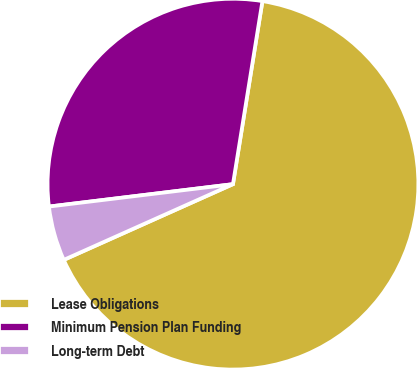Convert chart to OTSL. <chart><loc_0><loc_0><loc_500><loc_500><pie_chart><fcel>Lease Obligations<fcel>Minimum Pension Plan Funding<fcel>Long-term Debt<nl><fcel>65.76%<fcel>29.47%<fcel>4.77%<nl></chart> 